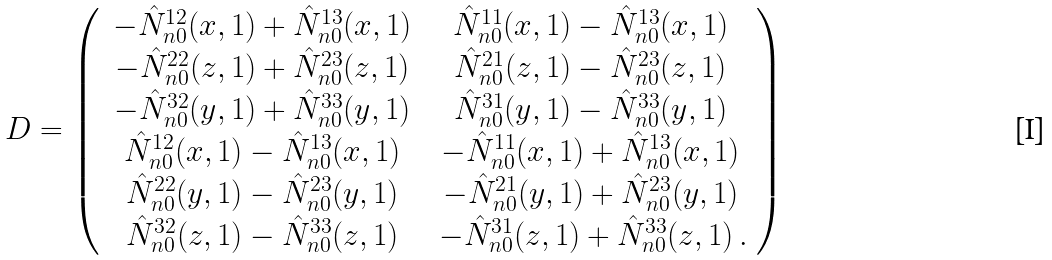Convert formula to latex. <formula><loc_0><loc_0><loc_500><loc_500>D = \left ( \begin{array} { c c } { { \, - \hat { N } _ { n 0 } ^ { 1 2 } ( x , 1 ) + \hat { N } _ { n 0 } ^ { 1 3 } ( x , 1 ) \, } } & { { \, \hat { N } _ { n 0 } ^ { 1 1 } ( x , 1 ) - \hat { N } _ { n 0 } ^ { 1 3 } ( x , 1 ) \, } } \\ { { \, - \hat { N } _ { n 0 } ^ { 2 2 } ( z , 1 ) + \hat { N } _ { n 0 } ^ { 2 3 } ( z , 1 ) \, } } & { { \, \hat { N } _ { n 0 } ^ { 2 1 } ( z , 1 ) - \hat { N } _ { n 0 } ^ { 2 3 } ( z , 1 ) \, } } \\ { { \, - \hat { N } _ { n 0 } ^ { 3 2 } ( y , 1 ) + \hat { N } _ { n 0 } ^ { 3 3 } ( y , 1 ) \, } } & { { \, \hat { N } _ { n 0 } ^ { 3 1 } ( y , 1 ) - \hat { N } _ { n 0 } ^ { 3 3 } ( y , 1 ) \, } } \\ { { \, \hat { N } _ { n 0 } ^ { 1 2 } ( x , 1 ) - \hat { N } _ { n 0 } ^ { 1 3 } ( x , 1 ) \, } } & { { \, - \hat { N } _ { n 0 } ^ { 1 1 } ( x , 1 ) + \hat { N } _ { n 0 } ^ { 1 3 } ( x , 1 ) \, } } \\ { { \, \hat { N } _ { n 0 } ^ { 2 2 } ( y , 1 ) - \hat { N } _ { n 0 } ^ { 2 3 } ( y , 1 ) \, } } & { { \, - \hat { N } _ { n 0 } ^ { 2 1 } ( y , 1 ) + \hat { N } _ { n 0 } ^ { 2 3 } ( y , 1 ) \, } } \\ { { \, \hat { N } _ { n 0 } ^ { 3 2 } ( z , 1 ) - \hat { N } _ { n 0 } ^ { 3 3 } ( z , 1 ) \, } } & { { \, - \hat { N } _ { n 0 } ^ { 3 1 } ( z , 1 ) + \hat { N } _ { n 0 } ^ { 3 3 } ( z , 1 ) \, . } } \end{array} \right )</formula> 